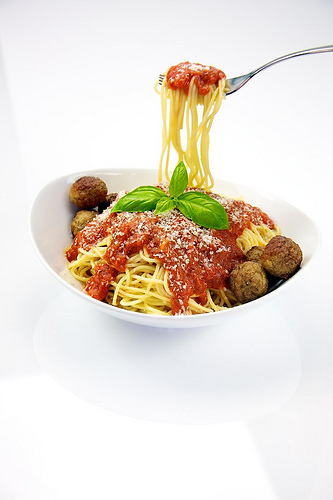<image>
Can you confirm if the noodle is under the sauce? Yes. The noodle is positioned underneath the sauce, with the sauce above it in the vertical space. 